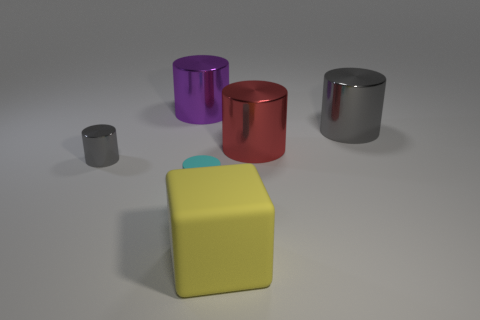Subtract all red spheres. How many gray cylinders are left? 2 Subtract all red metal cylinders. How many cylinders are left? 4 Add 1 gray things. How many objects exist? 7 Subtract all gray cylinders. How many cylinders are left? 3 Subtract all cylinders. How many objects are left? 1 Subtract all gray cylinders. Subtract all green balls. How many cylinders are left? 3 Subtract all gray objects. Subtract all large purple metal objects. How many objects are left? 3 Add 3 small gray shiny cylinders. How many small gray shiny cylinders are left? 4 Add 1 cyan cylinders. How many cyan cylinders exist? 2 Subtract 0 cyan balls. How many objects are left? 6 